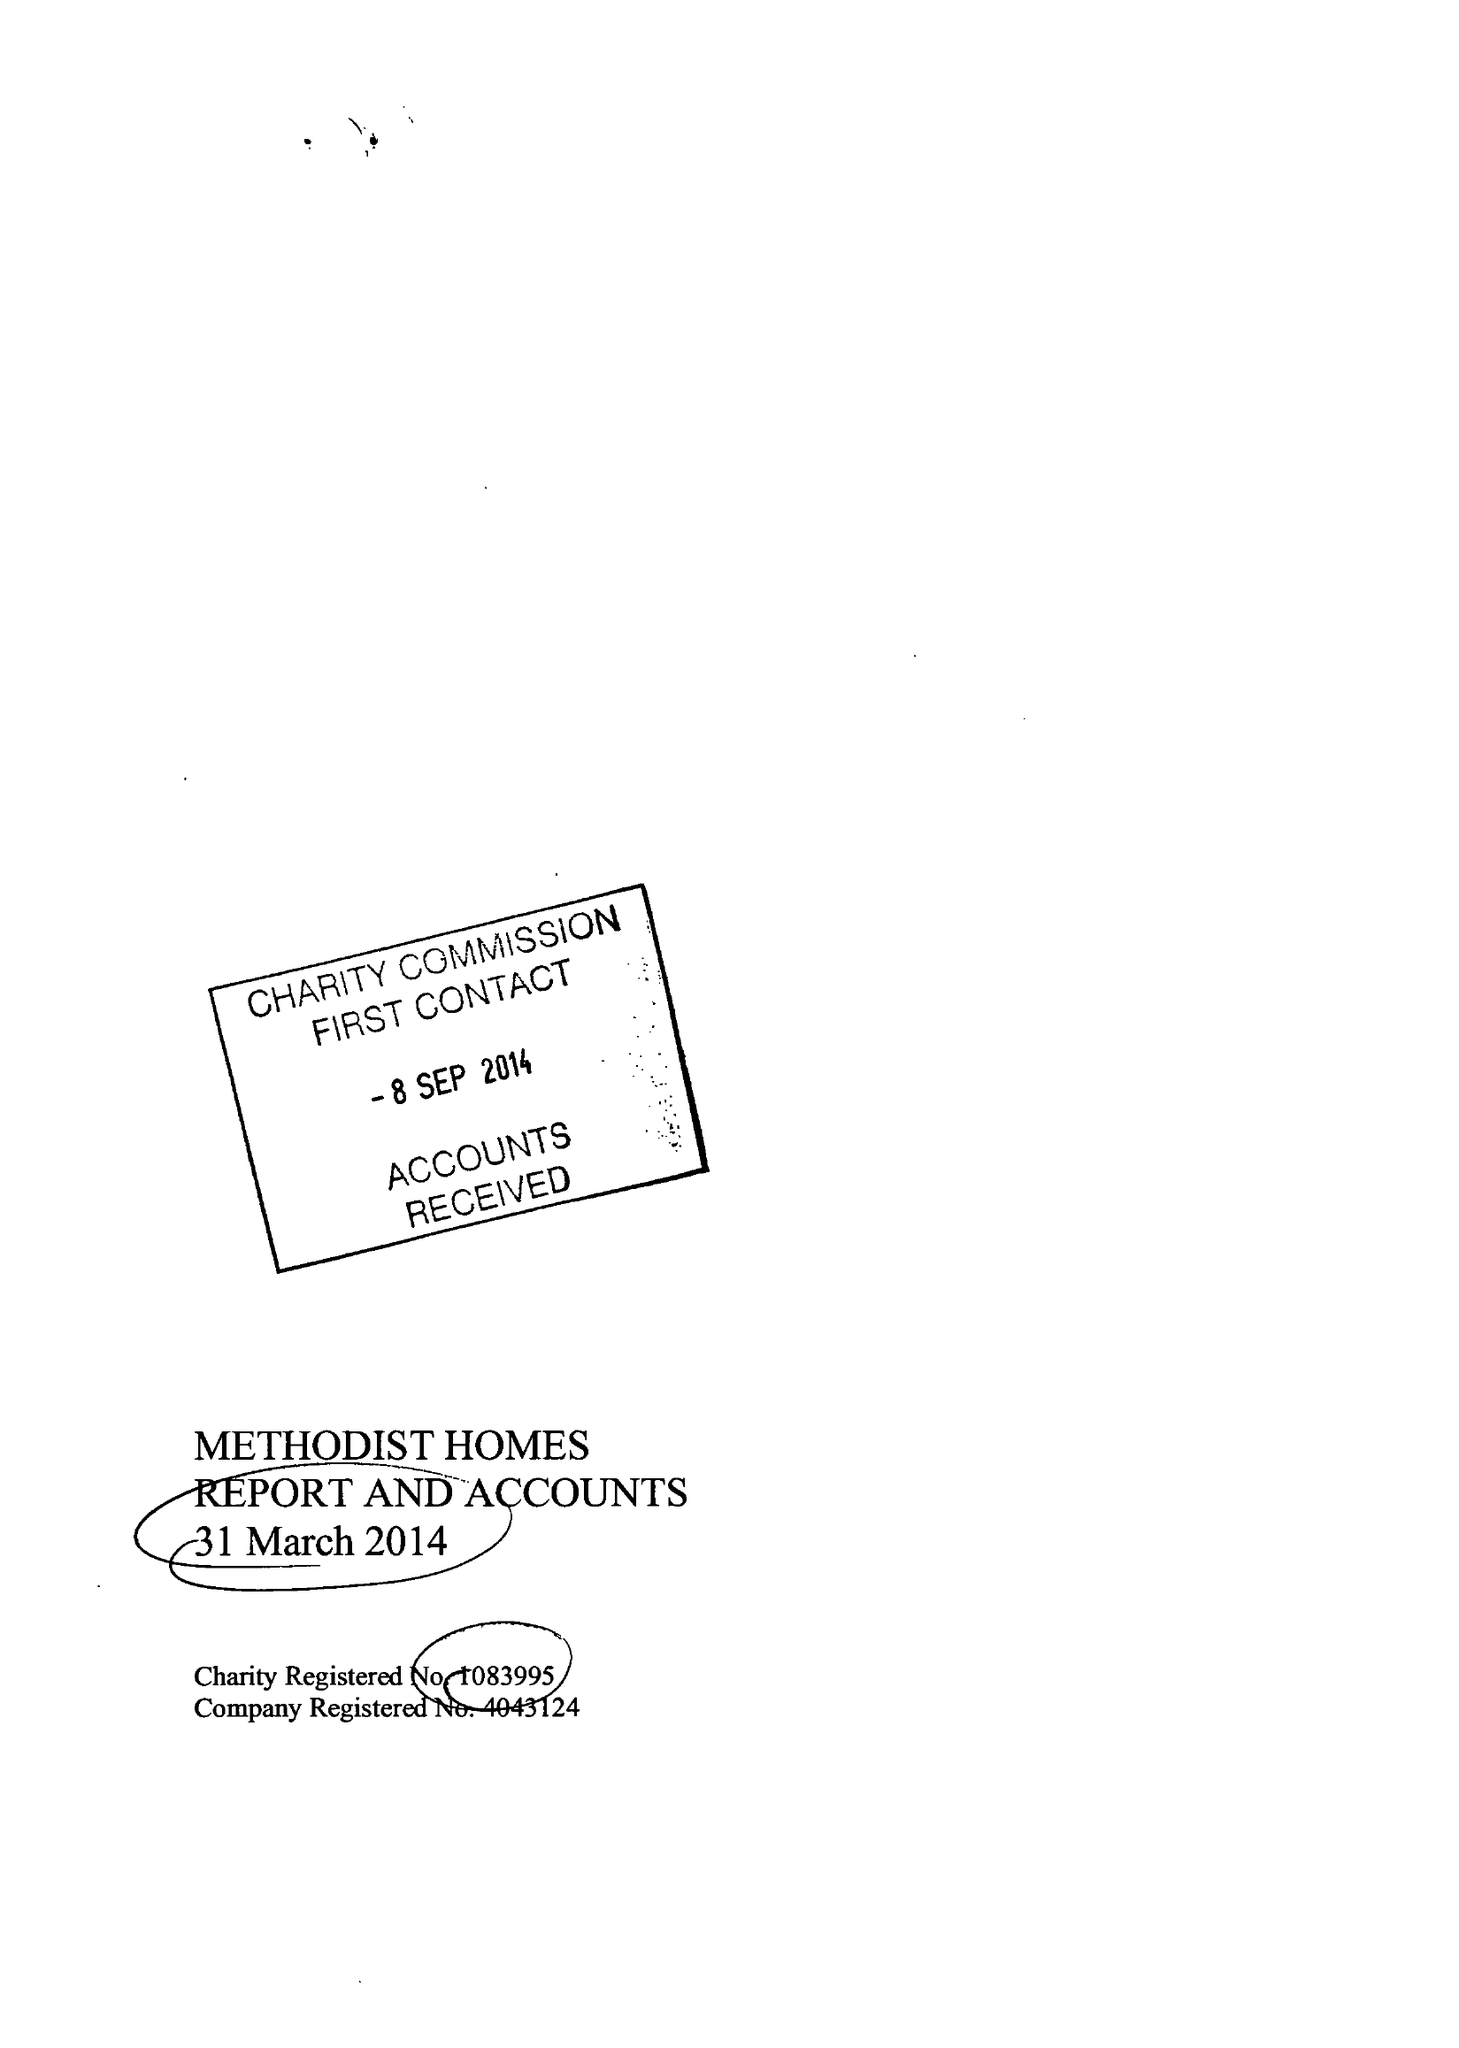What is the value for the charity_number?
Answer the question using a single word or phrase. 1083995 